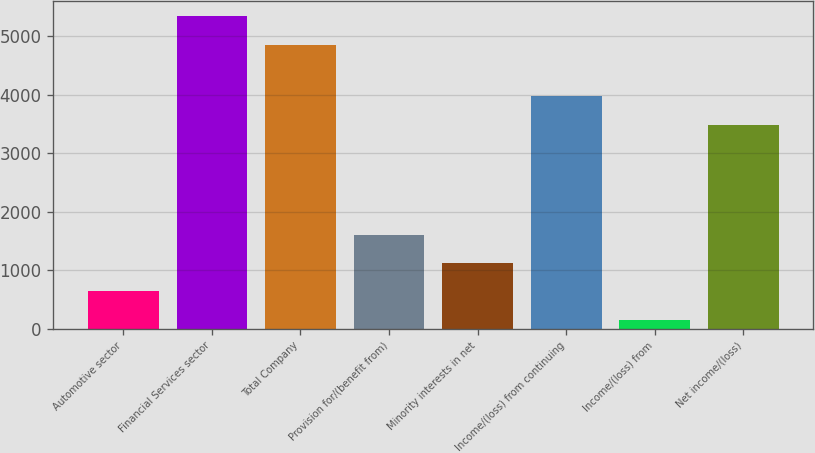Convert chart to OTSL. <chart><loc_0><loc_0><loc_500><loc_500><bar_chart><fcel>Automotive sector<fcel>Financial Services sector<fcel>Total Company<fcel>Provision for/(benefit from)<fcel>Minority interests in net<fcel>Income/(loss) from continuing<fcel>Income/(loss) from<fcel>Net income/(loss)<nl><fcel>633.1<fcel>5339.1<fcel>4853<fcel>1605.3<fcel>1119.2<fcel>3973.1<fcel>147<fcel>3487<nl></chart> 